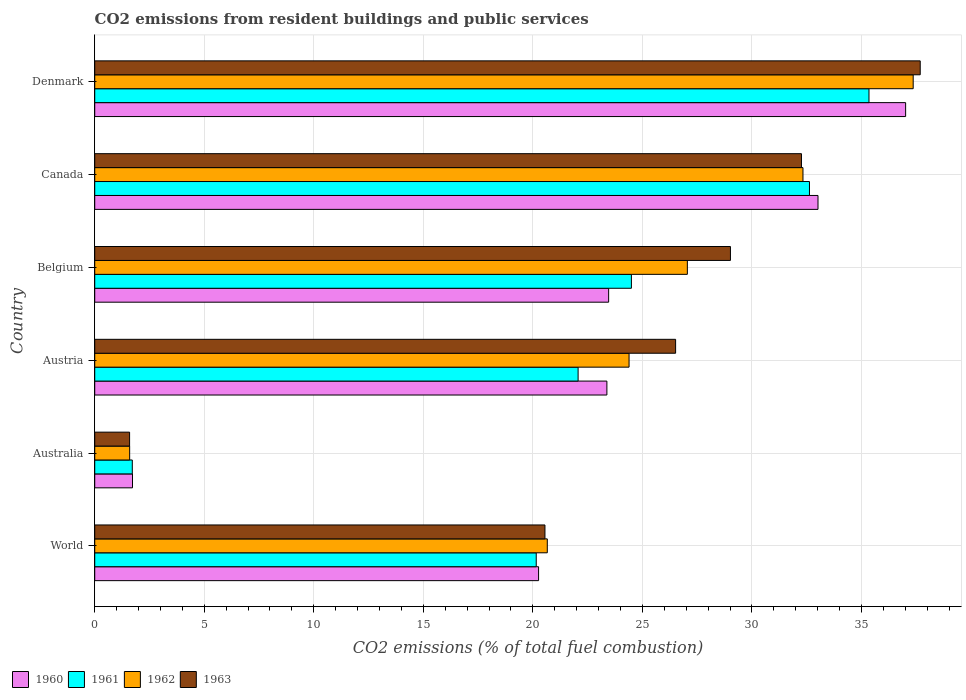How many different coloured bars are there?
Provide a succinct answer. 4. How many groups of bars are there?
Ensure brevity in your answer.  6. Are the number of bars per tick equal to the number of legend labels?
Make the answer very short. Yes. How many bars are there on the 1st tick from the top?
Your answer should be very brief. 4. How many bars are there on the 3rd tick from the bottom?
Offer a very short reply. 4. What is the label of the 6th group of bars from the top?
Provide a succinct answer. World. What is the total CO2 emitted in 1963 in Australia?
Offer a terse response. 1.59. Across all countries, what is the maximum total CO2 emitted in 1960?
Your answer should be compact. 37.02. Across all countries, what is the minimum total CO2 emitted in 1962?
Offer a terse response. 1.59. What is the total total CO2 emitted in 1963 in the graph?
Offer a terse response. 147.62. What is the difference between the total CO2 emitted in 1963 in Australia and that in Denmark?
Your answer should be compact. -36.09. What is the difference between the total CO2 emitted in 1963 in Australia and the total CO2 emitted in 1961 in Canada?
Keep it short and to the point. -31.03. What is the average total CO2 emitted in 1961 per country?
Keep it short and to the point. 22.73. What is the difference between the total CO2 emitted in 1961 and total CO2 emitted in 1960 in Belgium?
Offer a terse response. 1.04. What is the ratio of the total CO2 emitted in 1962 in Australia to that in Canada?
Give a very brief answer. 0.05. Is the total CO2 emitted in 1963 in Austria less than that in Denmark?
Provide a short and direct response. Yes. Is the difference between the total CO2 emitted in 1961 in Australia and Canada greater than the difference between the total CO2 emitted in 1960 in Australia and Canada?
Offer a very short reply. Yes. What is the difference between the highest and the second highest total CO2 emitted in 1961?
Your answer should be compact. 2.72. What is the difference between the highest and the lowest total CO2 emitted in 1960?
Provide a short and direct response. 35.29. In how many countries, is the total CO2 emitted in 1962 greater than the average total CO2 emitted in 1962 taken over all countries?
Offer a very short reply. 4. Is the sum of the total CO2 emitted in 1961 in Austria and World greater than the maximum total CO2 emitted in 1963 across all countries?
Keep it short and to the point. Yes. How many bars are there?
Your response must be concise. 24. How many countries are there in the graph?
Make the answer very short. 6. Are the values on the major ticks of X-axis written in scientific E-notation?
Your response must be concise. No. Does the graph contain any zero values?
Offer a terse response. No. How many legend labels are there?
Your answer should be compact. 4. What is the title of the graph?
Your response must be concise. CO2 emissions from resident buildings and public services. Does "1960" appear as one of the legend labels in the graph?
Offer a terse response. Yes. What is the label or title of the X-axis?
Keep it short and to the point. CO2 emissions (% of total fuel combustion). What is the label or title of the Y-axis?
Your answer should be compact. Country. What is the CO2 emissions (% of total fuel combustion) in 1960 in World?
Offer a very short reply. 20.26. What is the CO2 emissions (% of total fuel combustion) of 1961 in World?
Offer a terse response. 20.15. What is the CO2 emissions (% of total fuel combustion) of 1962 in World?
Your response must be concise. 20.66. What is the CO2 emissions (% of total fuel combustion) of 1963 in World?
Ensure brevity in your answer.  20.55. What is the CO2 emissions (% of total fuel combustion) of 1960 in Australia?
Give a very brief answer. 1.72. What is the CO2 emissions (% of total fuel combustion) in 1961 in Australia?
Offer a terse response. 1.71. What is the CO2 emissions (% of total fuel combustion) in 1962 in Australia?
Offer a terse response. 1.59. What is the CO2 emissions (% of total fuel combustion) of 1963 in Australia?
Offer a terse response. 1.59. What is the CO2 emissions (% of total fuel combustion) in 1960 in Austria?
Provide a short and direct response. 23.38. What is the CO2 emissions (% of total fuel combustion) of 1961 in Austria?
Your response must be concise. 22.06. What is the CO2 emissions (% of total fuel combustion) of 1962 in Austria?
Ensure brevity in your answer.  24.39. What is the CO2 emissions (% of total fuel combustion) in 1963 in Austria?
Your response must be concise. 26.52. What is the CO2 emissions (% of total fuel combustion) of 1960 in Belgium?
Give a very brief answer. 23.46. What is the CO2 emissions (% of total fuel combustion) of 1961 in Belgium?
Make the answer very short. 24.5. What is the CO2 emissions (% of total fuel combustion) in 1962 in Belgium?
Your response must be concise. 27.05. What is the CO2 emissions (% of total fuel combustion) of 1963 in Belgium?
Offer a very short reply. 29.02. What is the CO2 emissions (% of total fuel combustion) of 1960 in Canada?
Keep it short and to the point. 33.01. What is the CO2 emissions (% of total fuel combustion) of 1961 in Canada?
Your answer should be very brief. 32.63. What is the CO2 emissions (% of total fuel combustion) of 1962 in Canada?
Your response must be concise. 32.33. What is the CO2 emissions (% of total fuel combustion) of 1963 in Canada?
Your response must be concise. 32.26. What is the CO2 emissions (% of total fuel combustion) of 1960 in Denmark?
Make the answer very short. 37.02. What is the CO2 emissions (% of total fuel combustion) of 1961 in Denmark?
Keep it short and to the point. 35.34. What is the CO2 emissions (% of total fuel combustion) in 1962 in Denmark?
Offer a terse response. 37.36. What is the CO2 emissions (% of total fuel combustion) in 1963 in Denmark?
Provide a succinct answer. 37.68. Across all countries, what is the maximum CO2 emissions (% of total fuel combustion) of 1960?
Give a very brief answer. 37.02. Across all countries, what is the maximum CO2 emissions (% of total fuel combustion) in 1961?
Your answer should be very brief. 35.34. Across all countries, what is the maximum CO2 emissions (% of total fuel combustion) in 1962?
Offer a very short reply. 37.36. Across all countries, what is the maximum CO2 emissions (% of total fuel combustion) in 1963?
Your answer should be very brief. 37.68. Across all countries, what is the minimum CO2 emissions (% of total fuel combustion) of 1960?
Make the answer very short. 1.72. Across all countries, what is the minimum CO2 emissions (% of total fuel combustion) of 1961?
Give a very brief answer. 1.71. Across all countries, what is the minimum CO2 emissions (% of total fuel combustion) in 1962?
Provide a succinct answer. 1.59. Across all countries, what is the minimum CO2 emissions (% of total fuel combustion) in 1963?
Your answer should be compact. 1.59. What is the total CO2 emissions (% of total fuel combustion) in 1960 in the graph?
Provide a short and direct response. 138.85. What is the total CO2 emissions (% of total fuel combustion) of 1961 in the graph?
Offer a very short reply. 136.4. What is the total CO2 emissions (% of total fuel combustion) in 1962 in the graph?
Offer a terse response. 143.38. What is the total CO2 emissions (% of total fuel combustion) of 1963 in the graph?
Keep it short and to the point. 147.62. What is the difference between the CO2 emissions (% of total fuel combustion) in 1960 in World and that in Australia?
Make the answer very short. 18.54. What is the difference between the CO2 emissions (% of total fuel combustion) of 1961 in World and that in Australia?
Make the answer very short. 18.44. What is the difference between the CO2 emissions (% of total fuel combustion) of 1962 in World and that in Australia?
Offer a terse response. 19.06. What is the difference between the CO2 emissions (% of total fuel combustion) of 1963 in World and that in Australia?
Your response must be concise. 18.96. What is the difference between the CO2 emissions (% of total fuel combustion) in 1960 in World and that in Austria?
Provide a succinct answer. -3.12. What is the difference between the CO2 emissions (% of total fuel combustion) in 1961 in World and that in Austria?
Give a very brief answer. -1.91. What is the difference between the CO2 emissions (% of total fuel combustion) in 1962 in World and that in Austria?
Provide a short and direct response. -3.73. What is the difference between the CO2 emissions (% of total fuel combustion) of 1963 in World and that in Austria?
Your answer should be very brief. -5.96. What is the difference between the CO2 emissions (% of total fuel combustion) in 1960 in World and that in Belgium?
Make the answer very short. -3.2. What is the difference between the CO2 emissions (% of total fuel combustion) in 1961 in World and that in Belgium?
Your response must be concise. -4.34. What is the difference between the CO2 emissions (% of total fuel combustion) of 1962 in World and that in Belgium?
Make the answer very short. -6.39. What is the difference between the CO2 emissions (% of total fuel combustion) in 1963 in World and that in Belgium?
Your response must be concise. -8.47. What is the difference between the CO2 emissions (% of total fuel combustion) of 1960 in World and that in Canada?
Offer a very short reply. -12.75. What is the difference between the CO2 emissions (% of total fuel combustion) in 1961 in World and that in Canada?
Ensure brevity in your answer.  -12.47. What is the difference between the CO2 emissions (% of total fuel combustion) of 1962 in World and that in Canada?
Keep it short and to the point. -11.67. What is the difference between the CO2 emissions (% of total fuel combustion) in 1963 in World and that in Canada?
Your answer should be very brief. -11.71. What is the difference between the CO2 emissions (% of total fuel combustion) of 1960 in World and that in Denmark?
Your answer should be compact. -16.76. What is the difference between the CO2 emissions (% of total fuel combustion) in 1961 in World and that in Denmark?
Give a very brief answer. -15.19. What is the difference between the CO2 emissions (% of total fuel combustion) of 1962 in World and that in Denmark?
Your answer should be very brief. -16.7. What is the difference between the CO2 emissions (% of total fuel combustion) in 1963 in World and that in Denmark?
Offer a terse response. -17.13. What is the difference between the CO2 emissions (% of total fuel combustion) of 1960 in Australia and that in Austria?
Your response must be concise. -21.65. What is the difference between the CO2 emissions (% of total fuel combustion) in 1961 in Australia and that in Austria?
Keep it short and to the point. -20.35. What is the difference between the CO2 emissions (% of total fuel combustion) in 1962 in Australia and that in Austria?
Provide a short and direct response. -22.8. What is the difference between the CO2 emissions (% of total fuel combustion) in 1963 in Australia and that in Austria?
Give a very brief answer. -24.92. What is the difference between the CO2 emissions (% of total fuel combustion) of 1960 in Australia and that in Belgium?
Provide a succinct answer. -21.73. What is the difference between the CO2 emissions (% of total fuel combustion) in 1961 in Australia and that in Belgium?
Provide a succinct answer. -22.78. What is the difference between the CO2 emissions (% of total fuel combustion) in 1962 in Australia and that in Belgium?
Provide a succinct answer. -25.46. What is the difference between the CO2 emissions (% of total fuel combustion) in 1963 in Australia and that in Belgium?
Make the answer very short. -27.43. What is the difference between the CO2 emissions (% of total fuel combustion) of 1960 in Australia and that in Canada?
Ensure brevity in your answer.  -31.29. What is the difference between the CO2 emissions (% of total fuel combustion) in 1961 in Australia and that in Canada?
Provide a succinct answer. -30.91. What is the difference between the CO2 emissions (% of total fuel combustion) of 1962 in Australia and that in Canada?
Give a very brief answer. -30.73. What is the difference between the CO2 emissions (% of total fuel combustion) in 1963 in Australia and that in Canada?
Provide a succinct answer. -30.67. What is the difference between the CO2 emissions (% of total fuel combustion) in 1960 in Australia and that in Denmark?
Your answer should be compact. -35.29. What is the difference between the CO2 emissions (% of total fuel combustion) in 1961 in Australia and that in Denmark?
Offer a very short reply. -33.63. What is the difference between the CO2 emissions (% of total fuel combustion) in 1962 in Australia and that in Denmark?
Ensure brevity in your answer.  -35.77. What is the difference between the CO2 emissions (% of total fuel combustion) of 1963 in Australia and that in Denmark?
Ensure brevity in your answer.  -36.09. What is the difference between the CO2 emissions (% of total fuel combustion) of 1960 in Austria and that in Belgium?
Offer a terse response. -0.08. What is the difference between the CO2 emissions (% of total fuel combustion) of 1961 in Austria and that in Belgium?
Your answer should be compact. -2.43. What is the difference between the CO2 emissions (% of total fuel combustion) of 1962 in Austria and that in Belgium?
Offer a terse response. -2.66. What is the difference between the CO2 emissions (% of total fuel combustion) of 1963 in Austria and that in Belgium?
Give a very brief answer. -2.5. What is the difference between the CO2 emissions (% of total fuel combustion) of 1960 in Austria and that in Canada?
Ensure brevity in your answer.  -9.64. What is the difference between the CO2 emissions (% of total fuel combustion) in 1961 in Austria and that in Canada?
Make the answer very short. -10.56. What is the difference between the CO2 emissions (% of total fuel combustion) in 1962 in Austria and that in Canada?
Provide a short and direct response. -7.94. What is the difference between the CO2 emissions (% of total fuel combustion) of 1963 in Austria and that in Canada?
Provide a short and direct response. -5.74. What is the difference between the CO2 emissions (% of total fuel combustion) in 1960 in Austria and that in Denmark?
Provide a succinct answer. -13.64. What is the difference between the CO2 emissions (% of total fuel combustion) in 1961 in Austria and that in Denmark?
Your answer should be very brief. -13.28. What is the difference between the CO2 emissions (% of total fuel combustion) in 1962 in Austria and that in Denmark?
Ensure brevity in your answer.  -12.97. What is the difference between the CO2 emissions (% of total fuel combustion) of 1963 in Austria and that in Denmark?
Keep it short and to the point. -11.17. What is the difference between the CO2 emissions (% of total fuel combustion) of 1960 in Belgium and that in Canada?
Offer a very short reply. -9.56. What is the difference between the CO2 emissions (% of total fuel combustion) in 1961 in Belgium and that in Canada?
Your response must be concise. -8.13. What is the difference between the CO2 emissions (% of total fuel combustion) of 1962 in Belgium and that in Canada?
Your answer should be very brief. -5.28. What is the difference between the CO2 emissions (% of total fuel combustion) in 1963 in Belgium and that in Canada?
Ensure brevity in your answer.  -3.24. What is the difference between the CO2 emissions (% of total fuel combustion) in 1960 in Belgium and that in Denmark?
Your answer should be compact. -13.56. What is the difference between the CO2 emissions (% of total fuel combustion) in 1961 in Belgium and that in Denmark?
Offer a very short reply. -10.85. What is the difference between the CO2 emissions (% of total fuel combustion) in 1962 in Belgium and that in Denmark?
Your answer should be compact. -10.31. What is the difference between the CO2 emissions (% of total fuel combustion) of 1963 in Belgium and that in Denmark?
Your answer should be compact. -8.66. What is the difference between the CO2 emissions (% of total fuel combustion) of 1960 in Canada and that in Denmark?
Your answer should be compact. -4. What is the difference between the CO2 emissions (% of total fuel combustion) of 1961 in Canada and that in Denmark?
Offer a very short reply. -2.72. What is the difference between the CO2 emissions (% of total fuel combustion) in 1962 in Canada and that in Denmark?
Give a very brief answer. -5.03. What is the difference between the CO2 emissions (% of total fuel combustion) of 1963 in Canada and that in Denmark?
Offer a very short reply. -5.42. What is the difference between the CO2 emissions (% of total fuel combustion) of 1960 in World and the CO2 emissions (% of total fuel combustion) of 1961 in Australia?
Keep it short and to the point. 18.55. What is the difference between the CO2 emissions (% of total fuel combustion) of 1960 in World and the CO2 emissions (% of total fuel combustion) of 1962 in Australia?
Offer a very short reply. 18.67. What is the difference between the CO2 emissions (% of total fuel combustion) of 1960 in World and the CO2 emissions (% of total fuel combustion) of 1963 in Australia?
Offer a terse response. 18.67. What is the difference between the CO2 emissions (% of total fuel combustion) in 1961 in World and the CO2 emissions (% of total fuel combustion) in 1962 in Australia?
Give a very brief answer. 18.56. What is the difference between the CO2 emissions (% of total fuel combustion) in 1961 in World and the CO2 emissions (% of total fuel combustion) in 1963 in Australia?
Provide a short and direct response. 18.56. What is the difference between the CO2 emissions (% of total fuel combustion) in 1962 in World and the CO2 emissions (% of total fuel combustion) in 1963 in Australia?
Your answer should be very brief. 19.07. What is the difference between the CO2 emissions (% of total fuel combustion) in 1960 in World and the CO2 emissions (% of total fuel combustion) in 1961 in Austria?
Offer a terse response. -1.8. What is the difference between the CO2 emissions (% of total fuel combustion) of 1960 in World and the CO2 emissions (% of total fuel combustion) of 1962 in Austria?
Provide a short and direct response. -4.13. What is the difference between the CO2 emissions (% of total fuel combustion) in 1960 in World and the CO2 emissions (% of total fuel combustion) in 1963 in Austria?
Ensure brevity in your answer.  -6.26. What is the difference between the CO2 emissions (% of total fuel combustion) in 1961 in World and the CO2 emissions (% of total fuel combustion) in 1962 in Austria?
Offer a very short reply. -4.24. What is the difference between the CO2 emissions (% of total fuel combustion) of 1961 in World and the CO2 emissions (% of total fuel combustion) of 1963 in Austria?
Your answer should be very brief. -6.36. What is the difference between the CO2 emissions (% of total fuel combustion) of 1962 in World and the CO2 emissions (% of total fuel combustion) of 1963 in Austria?
Keep it short and to the point. -5.86. What is the difference between the CO2 emissions (% of total fuel combustion) in 1960 in World and the CO2 emissions (% of total fuel combustion) in 1961 in Belgium?
Ensure brevity in your answer.  -4.24. What is the difference between the CO2 emissions (% of total fuel combustion) of 1960 in World and the CO2 emissions (% of total fuel combustion) of 1962 in Belgium?
Offer a very short reply. -6.79. What is the difference between the CO2 emissions (% of total fuel combustion) in 1960 in World and the CO2 emissions (% of total fuel combustion) in 1963 in Belgium?
Ensure brevity in your answer.  -8.76. What is the difference between the CO2 emissions (% of total fuel combustion) of 1961 in World and the CO2 emissions (% of total fuel combustion) of 1962 in Belgium?
Your answer should be compact. -6.9. What is the difference between the CO2 emissions (% of total fuel combustion) in 1961 in World and the CO2 emissions (% of total fuel combustion) in 1963 in Belgium?
Provide a short and direct response. -8.87. What is the difference between the CO2 emissions (% of total fuel combustion) in 1962 in World and the CO2 emissions (% of total fuel combustion) in 1963 in Belgium?
Provide a succinct answer. -8.36. What is the difference between the CO2 emissions (% of total fuel combustion) of 1960 in World and the CO2 emissions (% of total fuel combustion) of 1961 in Canada?
Offer a terse response. -12.37. What is the difference between the CO2 emissions (% of total fuel combustion) in 1960 in World and the CO2 emissions (% of total fuel combustion) in 1962 in Canada?
Your response must be concise. -12.07. What is the difference between the CO2 emissions (% of total fuel combustion) of 1960 in World and the CO2 emissions (% of total fuel combustion) of 1963 in Canada?
Give a very brief answer. -12. What is the difference between the CO2 emissions (% of total fuel combustion) of 1961 in World and the CO2 emissions (% of total fuel combustion) of 1962 in Canada?
Keep it short and to the point. -12.18. What is the difference between the CO2 emissions (% of total fuel combustion) of 1961 in World and the CO2 emissions (% of total fuel combustion) of 1963 in Canada?
Give a very brief answer. -12.11. What is the difference between the CO2 emissions (% of total fuel combustion) of 1962 in World and the CO2 emissions (% of total fuel combustion) of 1963 in Canada?
Give a very brief answer. -11.6. What is the difference between the CO2 emissions (% of total fuel combustion) of 1960 in World and the CO2 emissions (% of total fuel combustion) of 1961 in Denmark?
Ensure brevity in your answer.  -15.08. What is the difference between the CO2 emissions (% of total fuel combustion) in 1960 in World and the CO2 emissions (% of total fuel combustion) in 1962 in Denmark?
Ensure brevity in your answer.  -17.1. What is the difference between the CO2 emissions (% of total fuel combustion) of 1960 in World and the CO2 emissions (% of total fuel combustion) of 1963 in Denmark?
Provide a succinct answer. -17.42. What is the difference between the CO2 emissions (% of total fuel combustion) of 1961 in World and the CO2 emissions (% of total fuel combustion) of 1962 in Denmark?
Your answer should be very brief. -17.21. What is the difference between the CO2 emissions (% of total fuel combustion) of 1961 in World and the CO2 emissions (% of total fuel combustion) of 1963 in Denmark?
Your response must be concise. -17.53. What is the difference between the CO2 emissions (% of total fuel combustion) of 1962 in World and the CO2 emissions (% of total fuel combustion) of 1963 in Denmark?
Ensure brevity in your answer.  -17.02. What is the difference between the CO2 emissions (% of total fuel combustion) in 1960 in Australia and the CO2 emissions (% of total fuel combustion) in 1961 in Austria?
Offer a terse response. -20.34. What is the difference between the CO2 emissions (% of total fuel combustion) of 1960 in Australia and the CO2 emissions (% of total fuel combustion) of 1962 in Austria?
Keep it short and to the point. -22.67. What is the difference between the CO2 emissions (% of total fuel combustion) in 1960 in Australia and the CO2 emissions (% of total fuel combustion) in 1963 in Austria?
Offer a very short reply. -24.79. What is the difference between the CO2 emissions (% of total fuel combustion) in 1961 in Australia and the CO2 emissions (% of total fuel combustion) in 1962 in Austria?
Your answer should be compact. -22.68. What is the difference between the CO2 emissions (% of total fuel combustion) of 1961 in Australia and the CO2 emissions (% of total fuel combustion) of 1963 in Austria?
Give a very brief answer. -24.8. What is the difference between the CO2 emissions (% of total fuel combustion) in 1962 in Australia and the CO2 emissions (% of total fuel combustion) in 1963 in Austria?
Your answer should be very brief. -24.92. What is the difference between the CO2 emissions (% of total fuel combustion) of 1960 in Australia and the CO2 emissions (% of total fuel combustion) of 1961 in Belgium?
Your answer should be very brief. -22.77. What is the difference between the CO2 emissions (% of total fuel combustion) in 1960 in Australia and the CO2 emissions (% of total fuel combustion) in 1962 in Belgium?
Make the answer very short. -25.33. What is the difference between the CO2 emissions (% of total fuel combustion) in 1960 in Australia and the CO2 emissions (% of total fuel combustion) in 1963 in Belgium?
Offer a terse response. -27.29. What is the difference between the CO2 emissions (% of total fuel combustion) in 1961 in Australia and the CO2 emissions (% of total fuel combustion) in 1962 in Belgium?
Provide a short and direct response. -25.34. What is the difference between the CO2 emissions (% of total fuel combustion) of 1961 in Australia and the CO2 emissions (% of total fuel combustion) of 1963 in Belgium?
Ensure brevity in your answer.  -27.3. What is the difference between the CO2 emissions (% of total fuel combustion) in 1962 in Australia and the CO2 emissions (% of total fuel combustion) in 1963 in Belgium?
Ensure brevity in your answer.  -27.42. What is the difference between the CO2 emissions (% of total fuel combustion) of 1960 in Australia and the CO2 emissions (% of total fuel combustion) of 1961 in Canada?
Your response must be concise. -30.9. What is the difference between the CO2 emissions (% of total fuel combustion) in 1960 in Australia and the CO2 emissions (% of total fuel combustion) in 1962 in Canada?
Give a very brief answer. -30.61. What is the difference between the CO2 emissions (% of total fuel combustion) in 1960 in Australia and the CO2 emissions (% of total fuel combustion) in 1963 in Canada?
Offer a very short reply. -30.54. What is the difference between the CO2 emissions (% of total fuel combustion) in 1961 in Australia and the CO2 emissions (% of total fuel combustion) in 1962 in Canada?
Make the answer very short. -30.61. What is the difference between the CO2 emissions (% of total fuel combustion) in 1961 in Australia and the CO2 emissions (% of total fuel combustion) in 1963 in Canada?
Make the answer very short. -30.55. What is the difference between the CO2 emissions (% of total fuel combustion) of 1962 in Australia and the CO2 emissions (% of total fuel combustion) of 1963 in Canada?
Your answer should be very brief. -30.67. What is the difference between the CO2 emissions (% of total fuel combustion) in 1960 in Australia and the CO2 emissions (% of total fuel combustion) in 1961 in Denmark?
Provide a short and direct response. -33.62. What is the difference between the CO2 emissions (% of total fuel combustion) of 1960 in Australia and the CO2 emissions (% of total fuel combustion) of 1962 in Denmark?
Keep it short and to the point. -35.64. What is the difference between the CO2 emissions (% of total fuel combustion) of 1960 in Australia and the CO2 emissions (% of total fuel combustion) of 1963 in Denmark?
Ensure brevity in your answer.  -35.96. What is the difference between the CO2 emissions (% of total fuel combustion) of 1961 in Australia and the CO2 emissions (% of total fuel combustion) of 1962 in Denmark?
Ensure brevity in your answer.  -35.65. What is the difference between the CO2 emissions (% of total fuel combustion) of 1961 in Australia and the CO2 emissions (% of total fuel combustion) of 1963 in Denmark?
Your response must be concise. -35.97. What is the difference between the CO2 emissions (% of total fuel combustion) in 1962 in Australia and the CO2 emissions (% of total fuel combustion) in 1963 in Denmark?
Your response must be concise. -36.09. What is the difference between the CO2 emissions (% of total fuel combustion) of 1960 in Austria and the CO2 emissions (% of total fuel combustion) of 1961 in Belgium?
Offer a very short reply. -1.12. What is the difference between the CO2 emissions (% of total fuel combustion) of 1960 in Austria and the CO2 emissions (% of total fuel combustion) of 1962 in Belgium?
Your answer should be compact. -3.67. What is the difference between the CO2 emissions (% of total fuel combustion) in 1960 in Austria and the CO2 emissions (% of total fuel combustion) in 1963 in Belgium?
Your response must be concise. -5.64. What is the difference between the CO2 emissions (% of total fuel combustion) of 1961 in Austria and the CO2 emissions (% of total fuel combustion) of 1962 in Belgium?
Your answer should be compact. -4.99. What is the difference between the CO2 emissions (% of total fuel combustion) of 1961 in Austria and the CO2 emissions (% of total fuel combustion) of 1963 in Belgium?
Your answer should be very brief. -6.95. What is the difference between the CO2 emissions (% of total fuel combustion) of 1962 in Austria and the CO2 emissions (% of total fuel combustion) of 1963 in Belgium?
Your response must be concise. -4.63. What is the difference between the CO2 emissions (% of total fuel combustion) of 1960 in Austria and the CO2 emissions (% of total fuel combustion) of 1961 in Canada?
Provide a succinct answer. -9.25. What is the difference between the CO2 emissions (% of total fuel combustion) in 1960 in Austria and the CO2 emissions (% of total fuel combustion) in 1962 in Canada?
Your answer should be compact. -8.95. What is the difference between the CO2 emissions (% of total fuel combustion) of 1960 in Austria and the CO2 emissions (% of total fuel combustion) of 1963 in Canada?
Offer a very short reply. -8.88. What is the difference between the CO2 emissions (% of total fuel combustion) in 1961 in Austria and the CO2 emissions (% of total fuel combustion) in 1962 in Canada?
Your answer should be compact. -10.26. What is the difference between the CO2 emissions (% of total fuel combustion) in 1961 in Austria and the CO2 emissions (% of total fuel combustion) in 1963 in Canada?
Make the answer very short. -10.2. What is the difference between the CO2 emissions (% of total fuel combustion) in 1962 in Austria and the CO2 emissions (% of total fuel combustion) in 1963 in Canada?
Provide a succinct answer. -7.87. What is the difference between the CO2 emissions (% of total fuel combustion) in 1960 in Austria and the CO2 emissions (% of total fuel combustion) in 1961 in Denmark?
Your response must be concise. -11.96. What is the difference between the CO2 emissions (% of total fuel combustion) in 1960 in Austria and the CO2 emissions (% of total fuel combustion) in 1962 in Denmark?
Ensure brevity in your answer.  -13.98. What is the difference between the CO2 emissions (% of total fuel combustion) in 1960 in Austria and the CO2 emissions (% of total fuel combustion) in 1963 in Denmark?
Keep it short and to the point. -14.3. What is the difference between the CO2 emissions (% of total fuel combustion) of 1961 in Austria and the CO2 emissions (% of total fuel combustion) of 1962 in Denmark?
Keep it short and to the point. -15.3. What is the difference between the CO2 emissions (% of total fuel combustion) in 1961 in Austria and the CO2 emissions (% of total fuel combustion) in 1963 in Denmark?
Keep it short and to the point. -15.62. What is the difference between the CO2 emissions (% of total fuel combustion) of 1962 in Austria and the CO2 emissions (% of total fuel combustion) of 1963 in Denmark?
Your answer should be very brief. -13.29. What is the difference between the CO2 emissions (% of total fuel combustion) of 1960 in Belgium and the CO2 emissions (% of total fuel combustion) of 1961 in Canada?
Provide a short and direct response. -9.17. What is the difference between the CO2 emissions (% of total fuel combustion) in 1960 in Belgium and the CO2 emissions (% of total fuel combustion) in 1962 in Canada?
Provide a short and direct response. -8.87. What is the difference between the CO2 emissions (% of total fuel combustion) in 1960 in Belgium and the CO2 emissions (% of total fuel combustion) in 1963 in Canada?
Ensure brevity in your answer.  -8.8. What is the difference between the CO2 emissions (% of total fuel combustion) in 1961 in Belgium and the CO2 emissions (% of total fuel combustion) in 1962 in Canada?
Your response must be concise. -7.83. What is the difference between the CO2 emissions (% of total fuel combustion) of 1961 in Belgium and the CO2 emissions (% of total fuel combustion) of 1963 in Canada?
Offer a terse response. -7.76. What is the difference between the CO2 emissions (% of total fuel combustion) of 1962 in Belgium and the CO2 emissions (% of total fuel combustion) of 1963 in Canada?
Provide a succinct answer. -5.21. What is the difference between the CO2 emissions (% of total fuel combustion) in 1960 in Belgium and the CO2 emissions (% of total fuel combustion) in 1961 in Denmark?
Offer a terse response. -11.88. What is the difference between the CO2 emissions (% of total fuel combustion) of 1960 in Belgium and the CO2 emissions (% of total fuel combustion) of 1962 in Denmark?
Keep it short and to the point. -13.9. What is the difference between the CO2 emissions (% of total fuel combustion) of 1960 in Belgium and the CO2 emissions (% of total fuel combustion) of 1963 in Denmark?
Provide a succinct answer. -14.22. What is the difference between the CO2 emissions (% of total fuel combustion) of 1961 in Belgium and the CO2 emissions (% of total fuel combustion) of 1962 in Denmark?
Give a very brief answer. -12.86. What is the difference between the CO2 emissions (% of total fuel combustion) of 1961 in Belgium and the CO2 emissions (% of total fuel combustion) of 1963 in Denmark?
Make the answer very short. -13.18. What is the difference between the CO2 emissions (% of total fuel combustion) of 1962 in Belgium and the CO2 emissions (% of total fuel combustion) of 1963 in Denmark?
Your response must be concise. -10.63. What is the difference between the CO2 emissions (% of total fuel combustion) in 1960 in Canada and the CO2 emissions (% of total fuel combustion) in 1961 in Denmark?
Give a very brief answer. -2.33. What is the difference between the CO2 emissions (% of total fuel combustion) of 1960 in Canada and the CO2 emissions (% of total fuel combustion) of 1962 in Denmark?
Provide a succinct answer. -4.35. What is the difference between the CO2 emissions (% of total fuel combustion) in 1960 in Canada and the CO2 emissions (% of total fuel combustion) in 1963 in Denmark?
Keep it short and to the point. -4.67. What is the difference between the CO2 emissions (% of total fuel combustion) of 1961 in Canada and the CO2 emissions (% of total fuel combustion) of 1962 in Denmark?
Provide a short and direct response. -4.73. What is the difference between the CO2 emissions (% of total fuel combustion) in 1961 in Canada and the CO2 emissions (% of total fuel combustion) in 1963 in Denmark?
Provide a succinct answer. -5.06. What is the difference between the CO2 emissions (% of total fuel combustion) of 1962 in Canada and the CO2 emissions (% of total fuel combustion) of 1963 in Denmark?
Give a very brief answer. -5.35. What is the average CO2 emissions (% of total fuel combustion) in 1960 per country?
Keep it short and to the point. 23.14. What is the average CO2 emissions (% of total fuel combustion) in 1961 per country?
Offer a very short reply. 22.73. What is the average CO2 emissions (% of total fuel combustion) in 1962 per country?
Your answer should be very brief. 23.9. What is the average CO2 emissions (% of total fuel combustion) of 1963 per country?
Offer a terse response. 24.6. What is the difference between the CO2 emissions (% of total fuel combustion) of 1960 and CO2 emissions (% of total fuel combustion) of 1961 in World?
Provide a short and direct response. 0.11. What is the difference between the CO2 emissions (% of total fuel combustion) of 1960 and CO2 emissions (% of total fuel combustion) of 1962 in World?
Offer a very short reply. -0.4. What is the difference between the CO2 emissions (% of total fuel combustion) of 1960 and CO2 emissions (% of total fuel combustion) of 1963 in World?
Offer a very short reply. -0.29. What is the difference between the CO2 emissions (% of total fuel combustion) of 1961 and CO2 emissions (% of total fuel combustion) of 1962 in World?
Your response must be concise. -0.5. What is the difference between the CO2 emissions (% of total fuel combustion) of 1961 and CO2 emissions (% of total fuel combustion) of 1963 in World?
Keep it short and to the point. -0.4. What is the difference between the CO2 emissions (% of total fuel combustion) in 1962 and CO2 emissions (% of total fuel combustion) in 1963 in World?
Give a very brief answer. 0.11. What is the difference between the CO2 emissions (% of total fuel combustion) in 1960 and CO2 emissions (% of total fuel combustion) in 1961 in Australia?
Provide a short and direct response. 0.01. What is the difference between the CO2 emissions (% of total fuel combustion) of 1960 and CO2 emissions (% of total fuel combustion) of 1962 in Australia?
Provide a short and direct response. 0.13. What is the difference between the CO2 emissions (% of total fuel combustion) in 1960 and CO2 emissions (% of total fuel combustion) in 1963 in Australia?
Make the answer very short. 0.13. What is the difference between the CO2 emissions (% of total fuel combustion) in 1961 and CO2 emissions (% of total fuel combustion) in 1962 in Australia?
Give a very brief answer. 0.12. What is the difference between the CO2 emissions (% of total fuel combustion) in 1961 and CO2 emissions (% of total fuel combustion) in 1963 in Australia?
Give a very brief answer. 0.12. What is the difference between the CO2 emissions (% of total fuel combustion) of 1962 and CO2 emissions (% of total fuel combustion) of 1963 in Australia?
Offer a terse response. 0. What is the difference between the CO2 emissions (% of total fuel combustion) in 1960 and CO2 emissions (% of total fuel combustion) in 1961 in Austria?
Provide a short and direct response. 1.31. What is the difference between the CO2 emissions (% of total fuel combustion) in 1960 and CO2 emissions (% of total fuel combustion) in 1962 in Austria?
Your answer should be compact. -1.01. What is the difference between the CO2 emissions (% of total fuel combustion) of 1960 and CO2 emissions (% of total fuel combustion) of 1963 in Austria?
Offer a very short reply. -3.14. What is the difference between the CO2 emissions (% of total fuel combustion) in 1961 and CO2 emissions (% of total fuel combustion) in 1962 in Austria?
Provide a short and direct response. -2.33. What is the difference between the CO2 emissions (% of total fuel combustion) in 1961 and CO2 emissions (% of total fuel combustion) in 1963 in Austria?
Provide a succinct answer. -4.45. What is the difference between the CO2 emissions (% of total fuel combustion) of 1962 and CO2 emissions (% of total fuel combustion) of 1963 in Austria?
Keep it short and to the point. -2.12. What is the difference between the CO2 emissions (% of total fuel combustion) in 1960 and CO2 emissions (% of total fuel combustion) in 1961 in Belgium?
Provide a succinct answer. -1.04. What is the difference between the CO2 emissions (% of total fuel combustion) of 1960 and CO2 emissions (% of total fuel combustion) of 1962 in Belgium?
Your answer should be very brief. -3.59. What is the difference between the CO2 emissions (% of total fuel combustion) of 1960 and CO2 emissions (% of total fuel combustion) of 1963 in Belgium?
Provide a succinct answer. -5.56. What is the difference between the CO2 emissions (% of total fuel combustion) in 1961 and CO2 emissions (% of total fuel combustion) in 1962 in Belgium?
Offer a terse response. -2.55. What is the difference between the CO2 emissions (% of total fuel combustion) in 1961 and CO2 emissions (% of total fuel combustion) in 1963 in Belgium?
Make the answer very short. -4.52. What is the difference between the CO2 emissions (% of total fuel combustion) of 1962 and CO2 emissions (% of total fuel combustion) of 1963 in Belgium?
Provide a short and direct response. -1.97. What is the difference between the CO2 emissions (% of total fuel combustion) in 1960 and CO2 emissions (% of total fuel combustion) in 1961 in Canada?
Ensure brevity in your answer.  0.39. What is the difference between the CO2 emissions (% of total fuel combustion) of 1960 and CO2 emissions (% of total fuel combustion) of 1962 in Canada?
Give a very brief answer. 0.69. What is the difference between the CO2 emissions (% of total fuel combustion) in 1960 and CO2 emissions (% of total fuel combustion) in 1963 in Canada?
Keep it short and to the point. 0.75. What is the difference between the CO2 emissions (% of total fuel combustion) of 1961 and CO2 emissions (% of total fuel combustion) of 1962 in Canada?
Provide a short and direct response. 0.3. What is the difference between the CO2 emissions (% of total fuel combustion) in 1961 and CO2 emissions (% of total fuel combustion) in 1963 in Canada?
Offer a terse response. 0.37. What is the difference between the CO2 emissions (% of total fuel combustion) in 1962 and CO2 emissions (% of total fuel combustion) in 1963 in Canada?
Offer a very short reply. 0.07. What is the difference between the CO2 emissions (% of total fuel combustion) of 1960 and CO2 emissions (% of total fuel combustion) of 1961 in Denmark?
Offer a terse response. 1.67. What is the difference between the CO2 emissions (% of total fuel combustion) in 1960 and CO2 emissions (% of total fuel combustion) in 1962 in Denmark?
Your response must be concise. -0.34. What is the difference between the CO2 emissions (% of total fuel combustion) in 1960 and CO2 emissions (% of total fuel combustion) in 1963 in Denmark?
Make the answer very short. -0.67. What is the difference between the CO2 emissions (% of total fuel combustion) of 1961 and CO2 emissions (% of total fuel combustion) of 1962 in Denmark?
Give a very brief answer. -2.02. What is the difference between the CO2 emissions (% of total fuel combustion) in 1961 and CO2 emissions (% of total fuel combustion) in 1963 in Denmark?
Your answer should be compact. -2.34. What is the difference between the CO2 emissions (% of total fuel combustion) of 1962 and CO2 emissions (% of total fuel combustion) of 1963 in Denmark?
Your answer should be compact. -0.32. What is the ratio of the CO2 emissions (% of total fuel combustion) of 1960 in World to that in Australia?
Make the answer very short. 11.75. What is the ratio of the CO2 emissions (% of total fuel combustion) of 1961 in World to that in Australia?
Your answer should be compact. 11.75. What is the ratio of the CO2 emissions (% of total fuel combustion) in 1962 in World to that in Australia?
Ensure brevity in your answer.  12.96. What is the ratio of the CO2 emissions (% of total fuel combustion) in 1963 in World to that in Australia?
Your answer should be compact. 12.92. What is the ratio of the CO2 emissions (% of total fuel combustion) in 1960 in World to that in Austria?
Provide a short and direct response. 0.87. What is the ratio of the CO2 emissions (% of total fuel combustion) in 1961 in World to that in Austria?
Ensure brevity in your answer.  0.91. What is the ratio of the CO2 emissions (% of total fuel combustion) in 1962 in World to that in Austria?
Provide a succinct answer. 0.85. What is the ratio of the CO2 emissions (% of total fuel combustion) in 1963 in World to that in Austria?
Your response must be concise. 0.78. What is the ratio of the CO2 emissions (% of total fuel combustion) in 1960 in World to that in Belgium?
Your answer should be compact. 0.86. What is the ratio of the CO2 emissions (% of total fuel combustion) in 1961 in World to that in Belgium?
Provide a short and direct response. 0.82. What is the ratio of the CO2 emissions (% of total fuel combustion) of 1962 in World to that in Belgium?
Offer a terse response. 0.76. What is the ratio of the CO2 emissions (% of total fuel combustion) in 1963 in World to that in Belgium?
Your response must be concise. 0.71. What is the ratio of the CO2 emissions (% of total fuel combustion) of 1960 in World to that in Canada?
Provide a short and direct response. 0.61. What is the ratio of the CO2 emissions (% of total fuel combustion) of 1961 in World to that in Canada?
Your response must be concise. 0.62. What is the ratio of the CO2 emissions (% of total fuel combustion) of 1962 in World to that in Canada?
Offer a terse response. 0.64. What is the ratio of the CO2 emissions (% of total fuel combustion) of 1963 in World to that in Canada?
Offer a very short reply. 0.64. What is the ratio of the CO2 emissions (% of total fuel combustion) in 1960 in World to that in Denmark?
Give a very brief answer. 0.55. What is the ratio of the CO2 emissions (% of total fuel combustion) of 1961 in World to that in Denmark?
Provide a short and direct response. 0.57. What is the ratio of the CO2 emissions (% of total fuel combustion) in 1962 in World to that in Denmark?
Ensure brevity in your answer.  0.55. What is the ratio of the CO2 emissions (% of total fuel combustion) of 1963 in World to that in Denmark?
Give a very brief answer. 0.55. What is the ratio of the CO2 emissions (% of total fuel combustion) of 1960 in Australia to that in Austria?
Your answer should be compact. 0.07. What is the ratio of the CO2 emissions (% of total fuel combustion) in 1961 in Australia to that in Austria?
Ensure brevity in your answer.  0.08. What is the ratio of the CO2 emissions (% of total fuel combustion) in 1962 in Australia to that in Austria?
Your answer should be very brief. 0.07. What is the ratio of the CO2 emissions (% of total fuel combustion) of 1963 in Australia to that in Austria?
Provide a succinct answer. 0.06. What is the ratio of the CO2 emissions (% of total fuel combustion) in 1960 in Australia to that in Belgium?
Offer a very short reply. 0.07. What is the ratio of the CO2 emissions (% of total fuel combustion) in 1961 in Australia to that in Belgium?
Ensure brevity in your answer.  0.07. What is the ratio of the CO2 emissions (% of total fuel combustion) in 1962 in Australia to that in Belgium?
Your answer should be compact. 0.06. What is the ratio of the CO2 emissions (% of total fuel combustion) of 1963 in Australia to that in Belgium?
Your response must be concise. 0.05. What is the ratio of the CO2 emissions (% of total fuel combustion) of 1960 in Australia to that in Canada?
Ensure brevity in your answer.  0.05. What is the ratio of the CO2 emissions (% of total fuel combustion) of 1961 in Australia to that in Canada?
Your answer should be very brief. 0.05. What is the ratio of the CO2 emissions (% of total fuel combustion) in 1962 in Australia to that in Canada?
Your answer should be very brief. 0.05. What is the ratio of the CO2 emissions (% of total fuel combustion) of 1963 in Australia to that in Canada?
Keep it short and to the point. 0.05. What is the ratio of the CO2 emissions (% of total fuel combustion) in 1960 in Australia to that in Denmark?
Your answer should be compact. 0.05. What is the ratio of the CO2 emissions (% of total fuel combustion) of 1961 in Australia to that in Denmark?
Your answer should be very brief. 0.05. What is the ratio of the CO2 emissions (% of total fuel combustion) in 1962 in Australia to that in Denmark?
Ensure brevity in your answer.  0.04. What is the ratio of the CO2 emissions (% of total fuel combustion) in 1963 in Australia to that in Denmark?
Offer a very short reply. 0.04. What is the ratio of the CO2 emissions (% of total fuel combustion) in 1960 in Austria to that in Belgium?
Offer a very short reply. 1. What is the ratio of the CO2 emissions (% of total fuel combustion) of 1961 in Austria to that in Belgium?
Keep it short and to the point. 0.9. What is the ratio of the CO2 emissions (% of total fuel combustion) in 1962 in Austria to that in Belgium?
Your response must be concise. 0.9. What is the ratio of the CO2 emissions (% of total fuel combustion) of 1963 in Austria to that in Belgium?
Give a very brief answer. 0.91. What is the ratio of the CO2 emissions (% of total fuel combustion) of 1960 in Austria to that in Canada?
Your answer should be compact. 0.71. What is the ratio of the CO2 emissions (% of total fuel combustion) in 1961 in Austria to that in Canada?
Offer a very short reply. 0.68. What is the ratio of the CO2 emissions (% of total fuel combustion) of 1962 in Austria to that in Canada?
Your answer should be compact. 0.75. What is the ratio of the CO2 emissions (% of total fuel combustion) of 1963 in Austria to that in Canada?
Your answer should be compact. 0.82. What is the ratio of the CO2 emissions (% of total fuel combustion) of 1960 in Austria to that in Denmark?
Offer a terse response. 0.63. What is the ratio of the CO2 emissions (% of total fuel combustion) of 1961 in Austria to that in Denmark?
Offer a terse response. 0.62. What is the ratio of the CO2 emissions (% of total fuel combustion) of 1962 in Austria to that in Denmark?
Give a very brief answer. 0.65. What is the ratio of the CO2 emissions (% of total fuel combustion) in 1963 in Austria to that in Denmark?
Ensure brevity in your answer.  0.7. What is the ratio of the CO2 emissions (% of total fuel combustion) of 1960 in Belgium to that in Canada?
Offer a terse response. 0.71. What is the ratio of the CO2 emissions (% of total fuel combustion) in 1961 in Belgium to that in Canada?
Keep it short and to the point. 0.75. What is the ratio of the CO2 emissions (% of total fuel combustion) of 1962 in Belgium to that in Canada?
Ensure brevity in your answer.  0.84. What is the ratio of the CO2 emissions (% of total fuel combustion) in 1963 in Belgium to that in Canada?
Give a very brief answer. 0.9. What is the ratio of the CO2 emissions (% of total fuel combustion) in 1960 in Belgium to that in Denmark?
Offer a very short reply. 0.63. What is the ratio of the CO2 emissions (% of total fuel combustion) of 1961 in Belgium to that in Denmark?
Offer a terse response. 0.69. What is the ratio of the CO2 emissions (% of total fuel combustion) of 1962 in Belgium to that in Denmark?
Your answer should be compact. 0.72. What is the ratio of the CO2 emissions (% of total fuel combustion) in 1963 in Belgium to that in Denmark?
Your response must be concise. 0.77. What is the ratio of the CO2 emissions (% of total fuel combustion) in 1960 in Canada to that in Denmark?
Offer a terse response. 0.89. What is the ratio of the CO2 emissions (% of total fuel combustion) in 1962 in Canada to that in Denmark?
Your response must be concise. 0.87. What is the ratio of the CO2 emissions (% of total fuel combustion) of 1963 in Canada to that in Denmark?
Provide a succinct answer. 0.86. What is the difference between the highest and the second highest CO2 emissions (% of total fuel combustion) of 1960?
Provide a succinct answer. 4. What is the difference between the highest and the second highest CO2 emissions (% of total fuel combustion) in 1961?
Keep it short and to the point. 2.72. What is the difference between the highest and the second highest CO2 emissions (% of total fuel combustion) of 1962?
Offer a very short reply. 5.03. What is the difference between the highest and the second highest CO2 emissions (% of total fuel combustion) of 1963?
Your response must be concise. 5.42. What is the difference between the highest and the lowest CO2 emissions (% of total fuel combustion) of 1960?
Your response must be concise. 35.29. What is the difference between the highest and the lowest CO2 emissions (% of total fuel combustion) of 1961?
Your answer should be compact. 33.63. What is the difference between the highest and the lowest CO2 emissions (% of total fuel combustion) in 1962?
Provide a short and direct response. 35.77. What is the difference between the highest and the lowest CO2 emissions (% of total fuel combustion) of 1963?
Give a very brief answer. 36.09. 